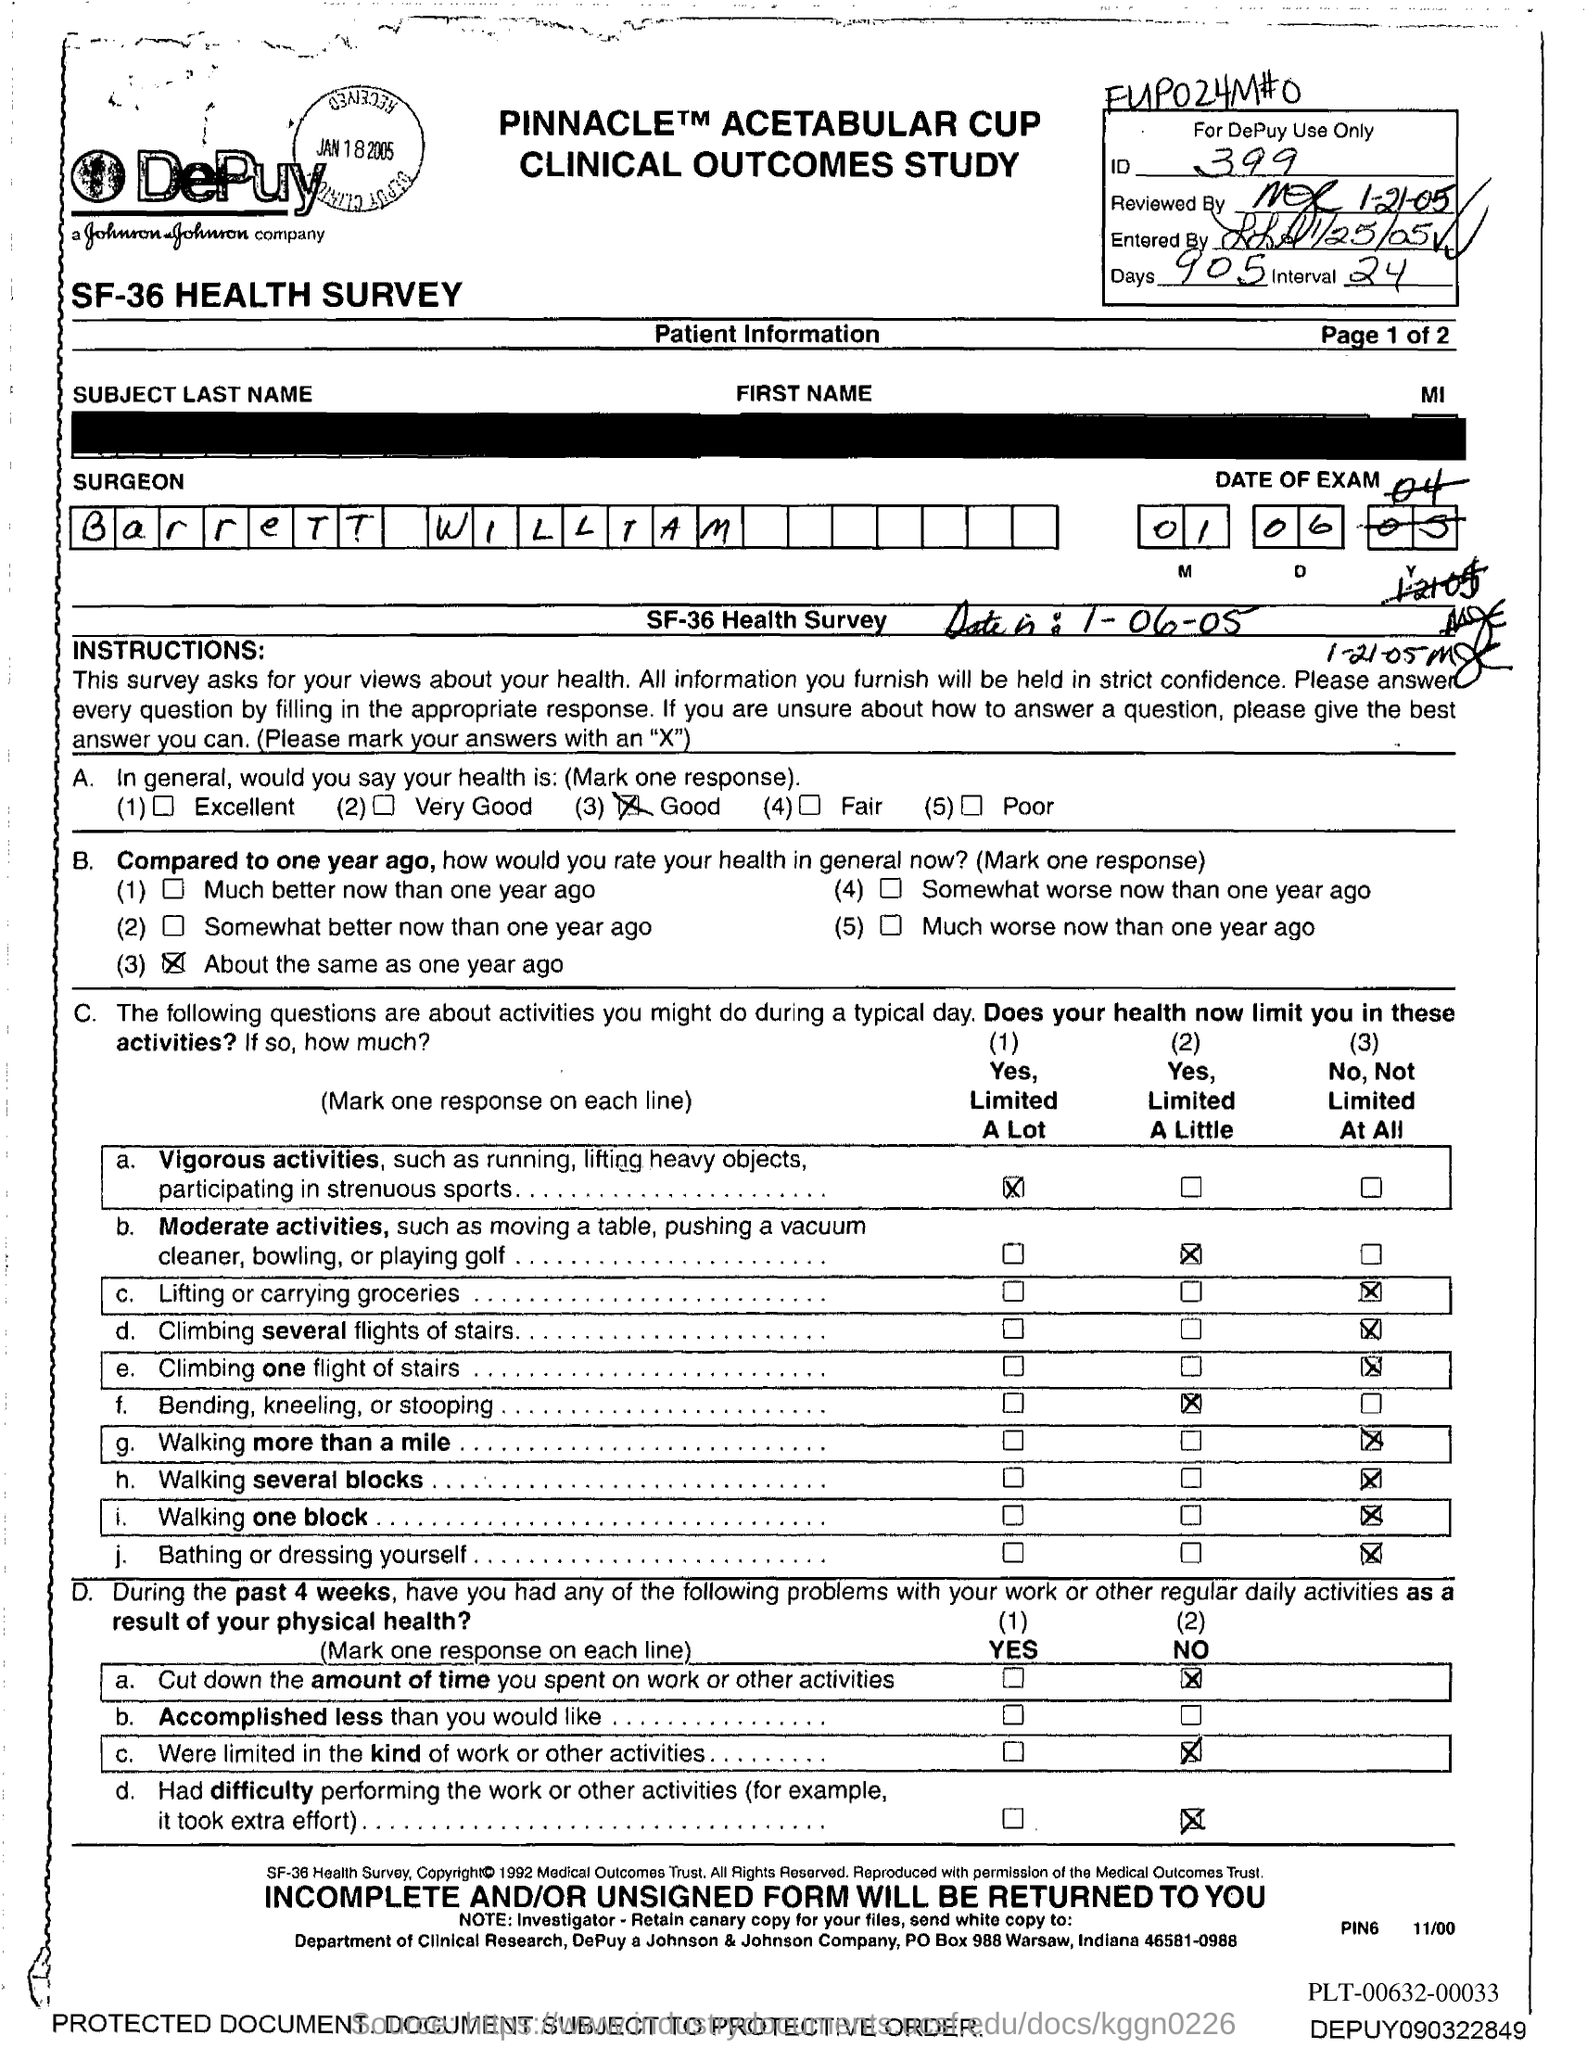Outline some significant characteristics in this image. Johnson & Johnson Company is located in the state of Indiana. What is the identification number?" the teacher asked the class. The student who was called upon replied, "It's 399... Johnson & Johnson Company's PO box number is 988. The name of the surgeon is Barrett William. 